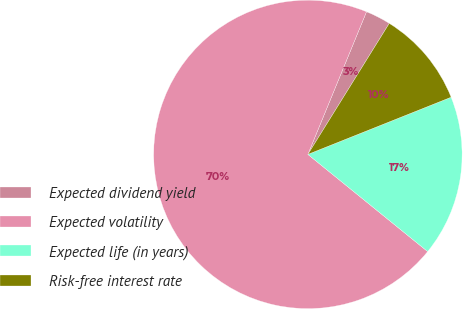<chart> <loc_0><loc_0><loc_500><loc_500><pie_chart><fcel>Expected dividend yield<fcel>Expected volatility<fcel>Expected life (in years)<fcel>Risk-free interest rate<nl><fcel>2.64%<fcel>70.36%<fcel>16.89%<fcel>10.11%<nl></chart> 